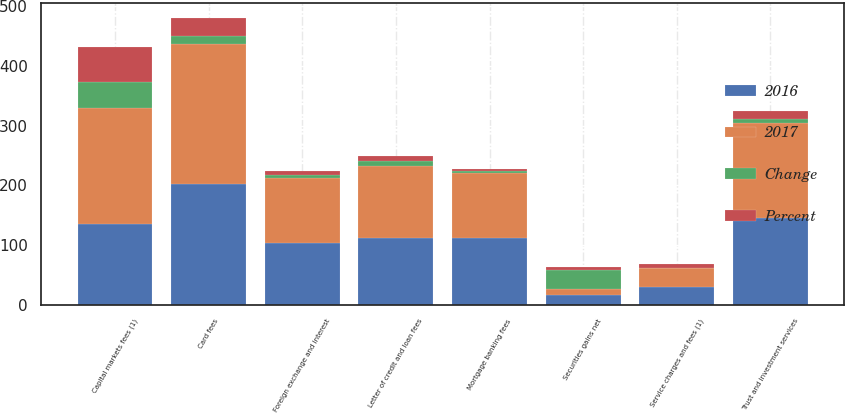Convert chart to OTSL. <chart><loc_0><loc_0><loc_500><loc_500><stacked_bar_chart><ecel><fcel>Service charges and fees (1)<fcel>Card fees<fcel>Capital markets fees (1)<fcel>Trust and investment services<fcel>Mortgage banking fees<fcel>Letter of credit and loan fees<fcel>Foreign exchange and interest<fcel>Securities gains net<nl><fcel>2017<fcel>30.5<fcel>233<fcel>194<fcel>158<fcel>108<fcel>121<fcel>109<fcel>11<nl><fcel>2016<fcel>30.5<fcel>203<fcel>136<fcel>146<fcel>112<fcel>112<fcel>103<fcel>16<nl><fcel>Percent<fcel>6<fcel>30<fcel>58<fcel>12<fcel>4<fcel>9<fcel>6<fcel>5<nl><fcel>Change<fcel>1<fcel>15<fcel>43<fcel>8<fcel>4<fcel>8<fcel>6<fcel>31<nl></chart> 